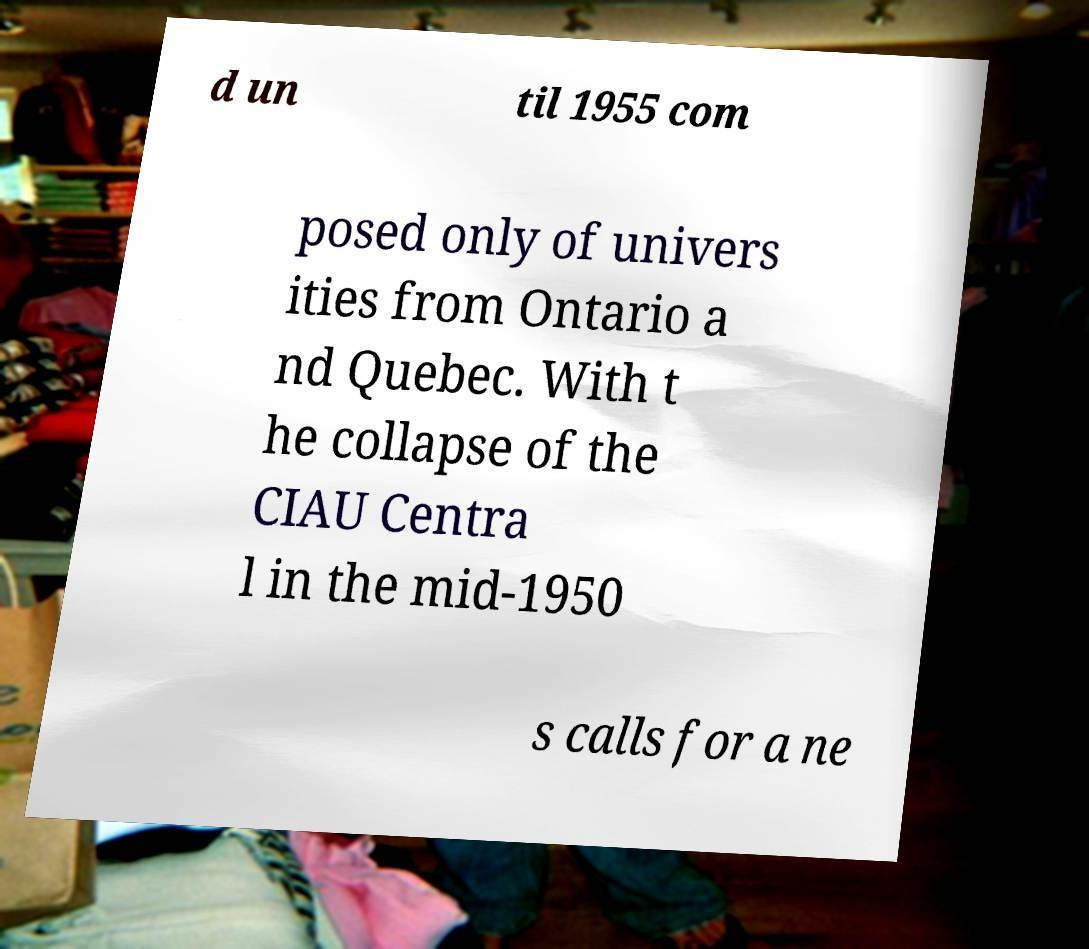Could you assist in decoding the text presented in this image and type it out clearly? d un til 1955 com posed only of univers ities from Ontario a nd Quebec. With t he collapse of the CIAU Centra l in the mid-1950 s calls for a ne 